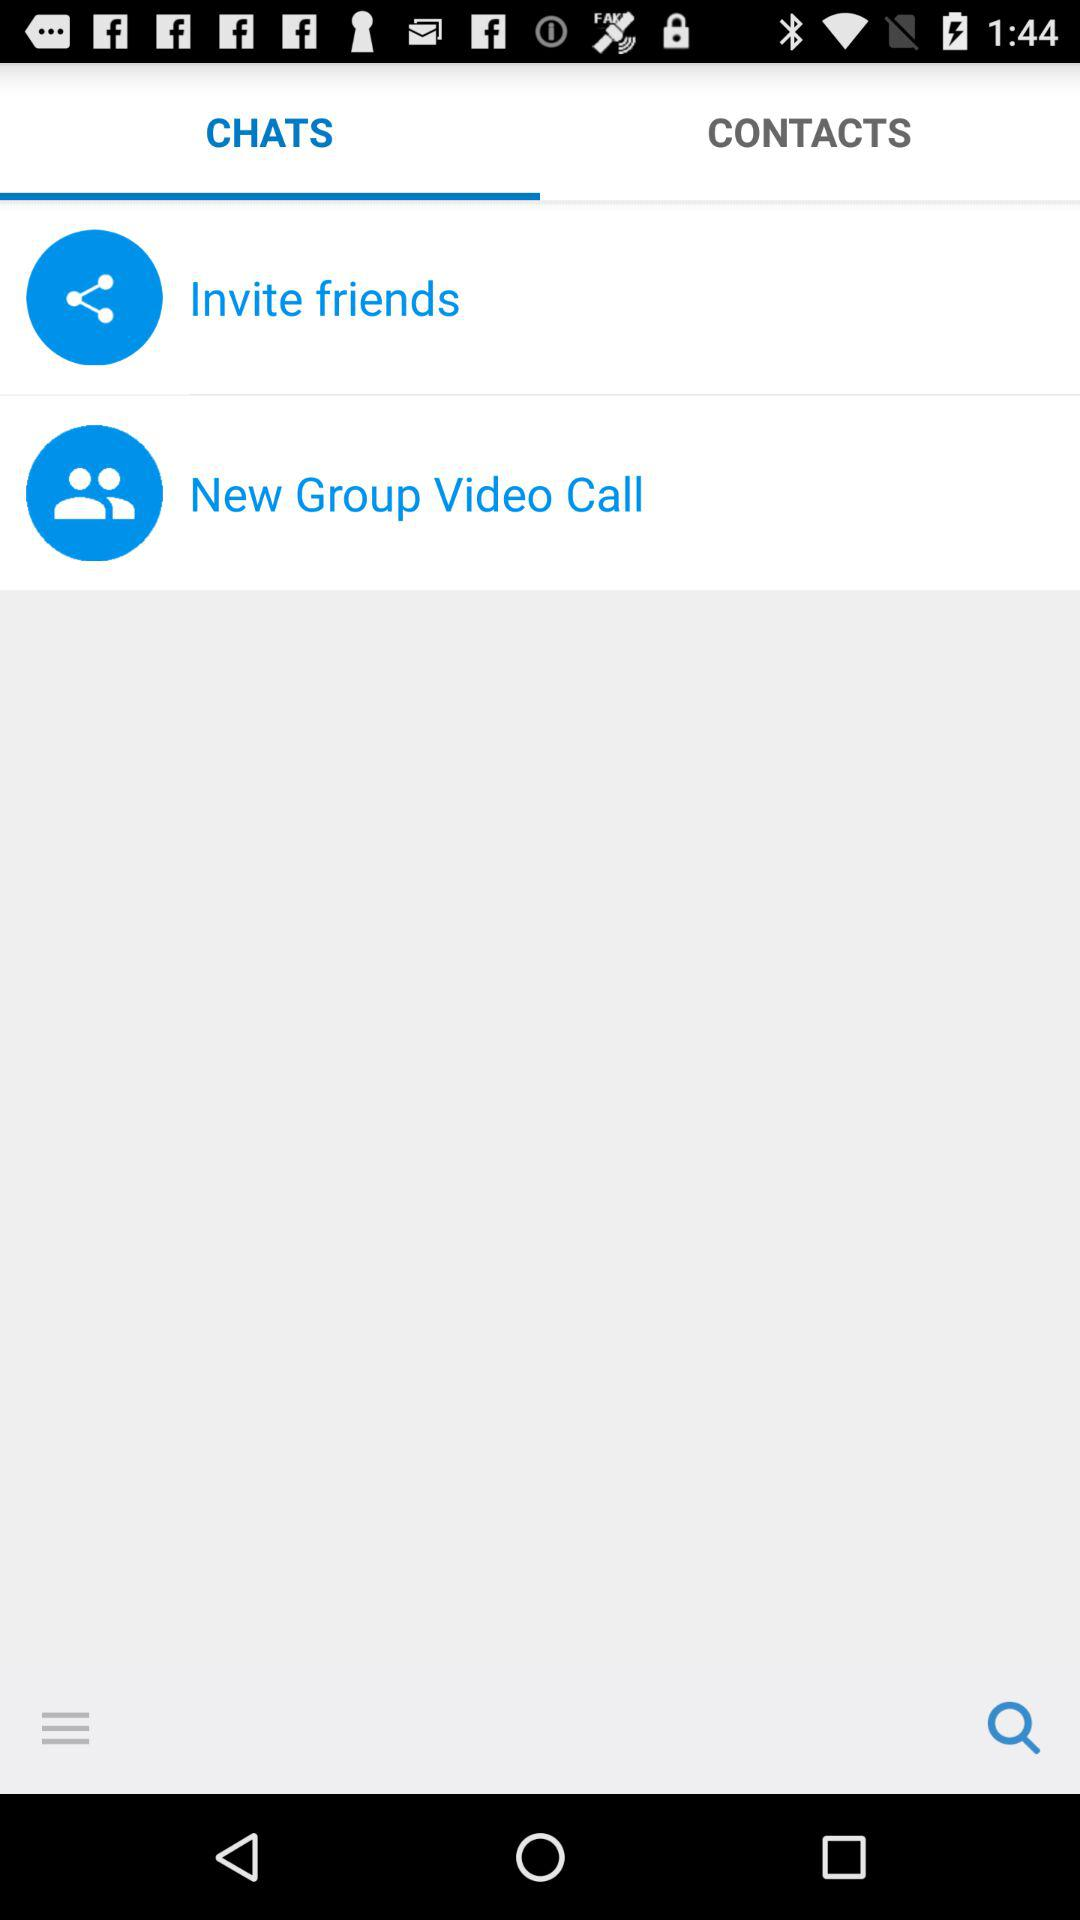Which tab am I on? You are on the "CHATS" tab. 